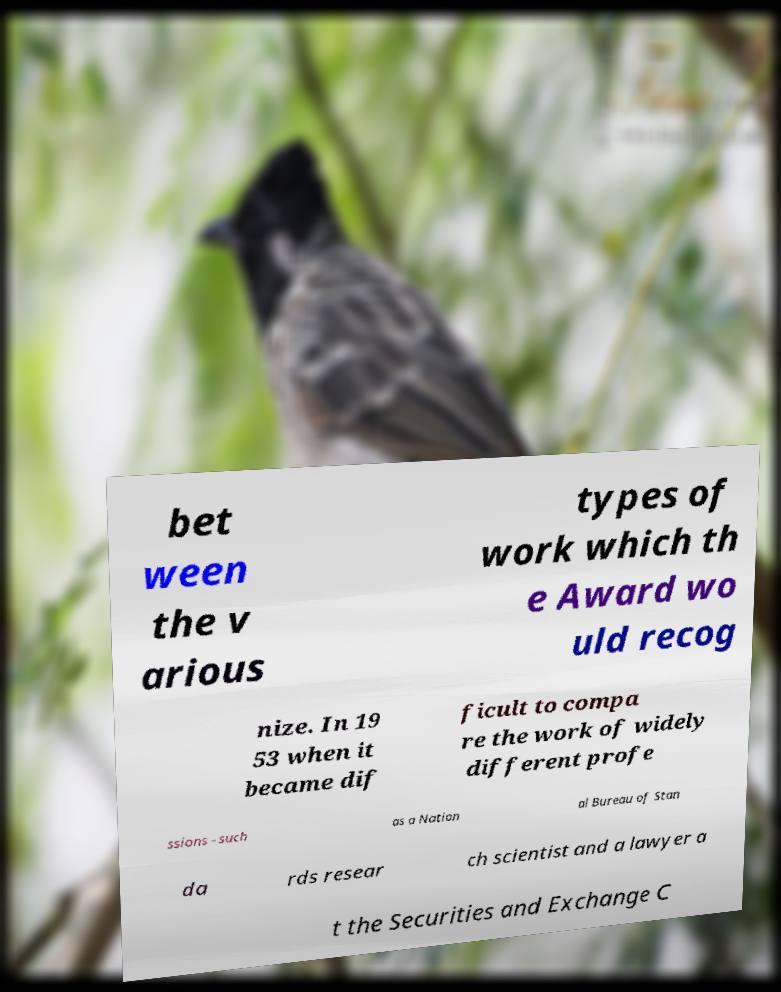I need the written content from this picture converted into text. Can you do that? bet ween the v arious types of work which th e Award wo uld recog nize. In 19 53 when it became dif ficult to compa re the work of widely different profe ssions - such as a Nation al Bureau of Stan da rds resear ch scientist and a lawyer a t the Securities and Exchange C 